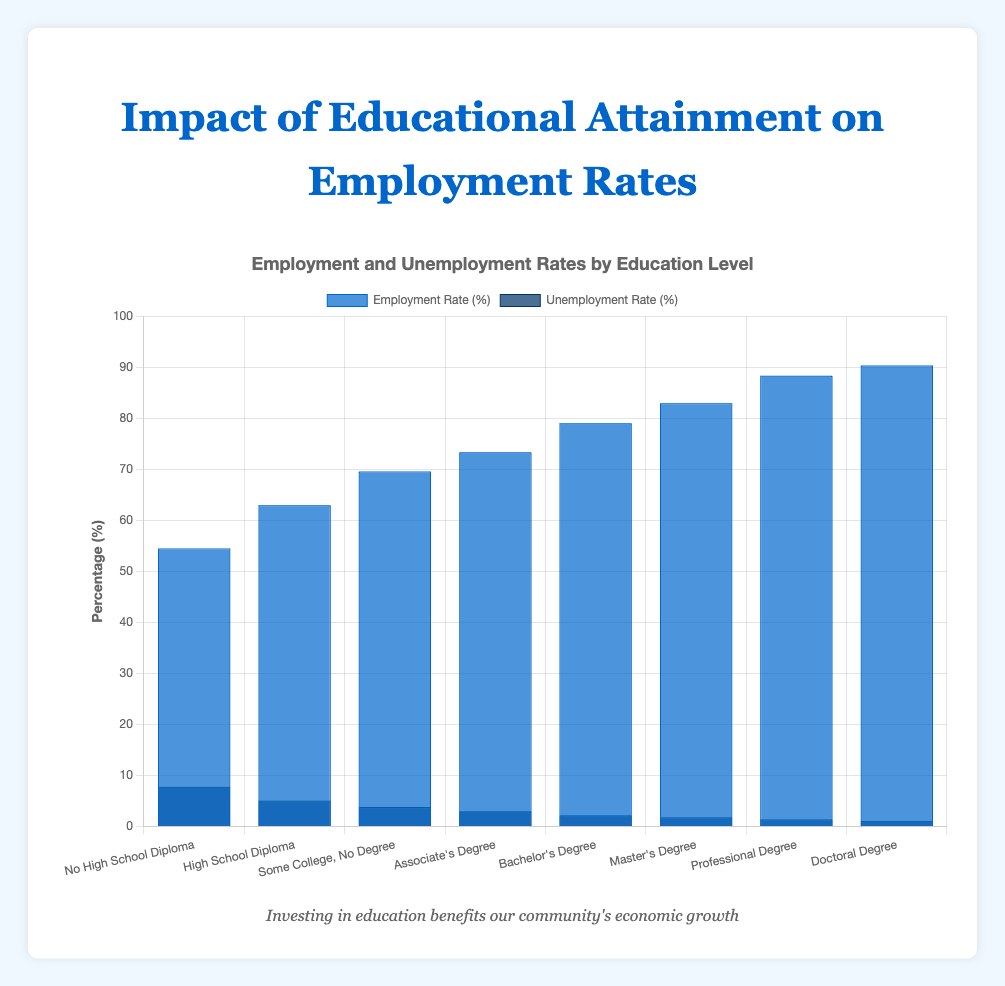What is the employment rate for individuals with a Master's Degree? The employment rate for individuals with a Master's Degree can be seen directly in the figure. It corresponds to the bar labeled "Master's Degree" under the "Employment Rate (%)" section.
Answer: 83.0% How does the unemployment rate for those with a Bachelor's Degree compare to those with a High School Diploma? The unemployment rate for individuals with a Bachelor's Degree and High School Diploma are directly provided in the figure. Compare the heights of the bars under "Unemployment Rate (%)" for the two education levels: Bachelor's Degree (2.2%) and High School Diploma (5.1%). Therefore, the unemployment rate for those with a Bachelor's Degree is lower.
Answer: Lower Which education level has the highest employment rate? Look at the "Employment Rate (%)" section and identify the bar that has the greatest height. The highest employment rate is for individuals with a Doctoral Degree at 90.4%.
Answer: Doctoral Degree What is the sum of the employment rates for "Associate's Degree" and "Bachelor's Degree"? Add the employment rates of "Associate's Degree" (73.4%) and "Bachelor's Degree" (79.1%) by referring to the "Employment Rate (%)" section in the figure. 73.4% + 79.1% = 152.5%.
Answer: 152.5% Which education level shows a greater decrease in unemployment rate compared to "High School Diploma": "Associate's Degree" or "Some College, No Degree"? Calculate the decrease for each one from the "High School Diploma" unemployment rate (5.1%). For "Associate's Degree," the unemployment rate is 3.0%, so the decrease is 5.1% - 3.0% = 2.1%. For "Some College, No Degree," the unemployment rate is 3.8%, so the decrease is 5.1% - 3.8% = 1.3%. Therefore, "Associate's Degree" shows a greater decrease.
Answer: Associate's Degree What is the difference between the employment rate of individuals with "No High School Diploma" and the unemployment rate of individuals with a "Professional Degree"? Subtract the unemployment rate for "Professional Degree" (1.4%) from the employment rate for "No High School Diploma" (54.5%) by referring to the corresponding sections in the figure. 54.5% - 1.4% = 53.1%.
Answer: 53.1% Is there any education level where both employment and unemployment rates add up exactly to 100%? Examine each education level's employment and unemployment rates from the figure. For each one, add the rates. None of them add up to exactly 100%.
Answer: No What is the average employment rate for "High School Diploma", "Some College, No Degree", and "Associate's Degree"? Add the employment rates for the three education levels and then divide by 3. (63.0% + 69.6% + 73.4%) / 3 = 68.67%.
Answer: 68.67% Which education level has the smallest unemployment rate? Look at the "Unemployment Rate (%)" section and identify the shortest bar. The unemployment rate is smallest for individuals with a Doctoral Degree at 1.1%.
Answer: Doctoral Degree 